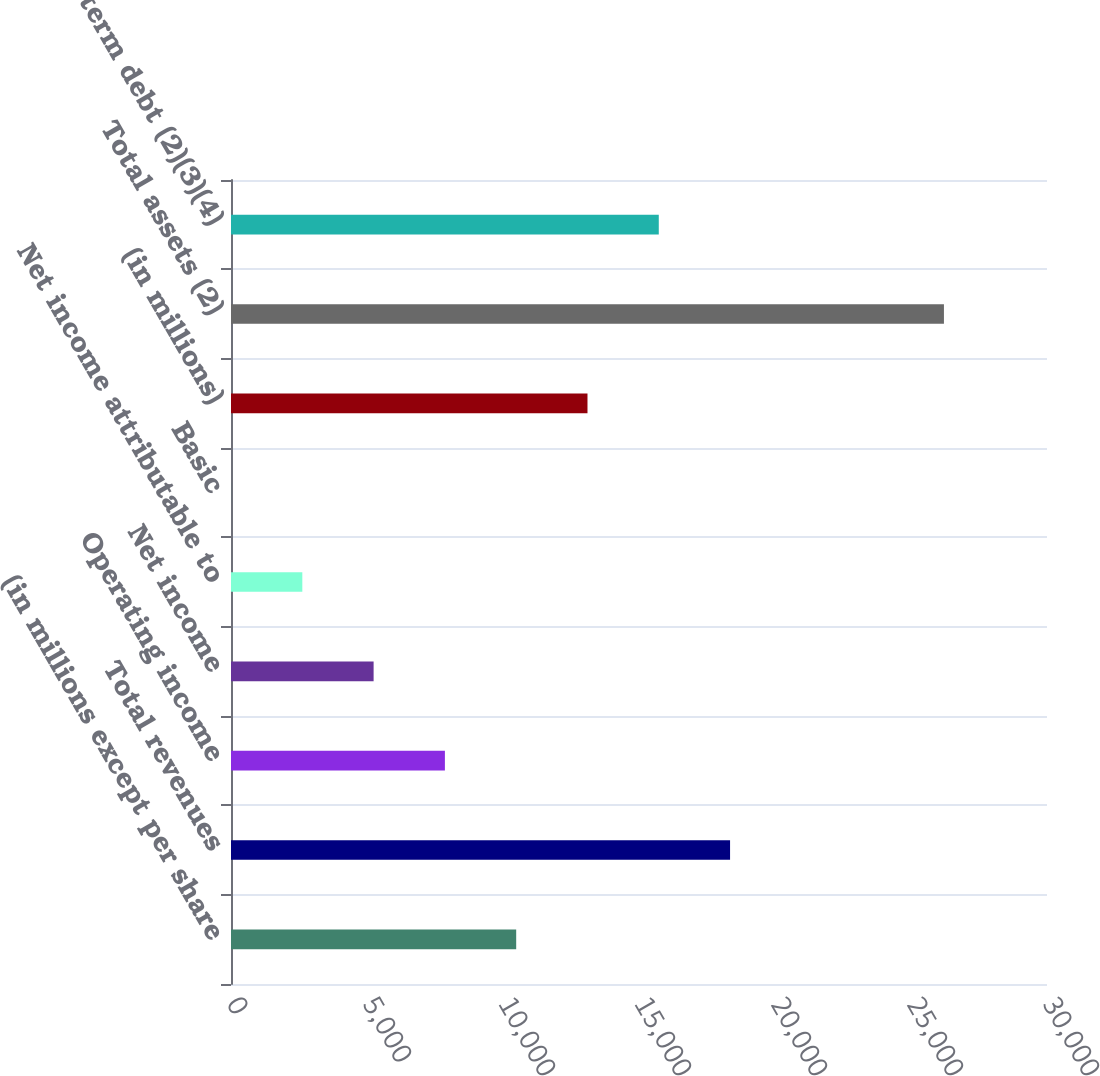Convert chart. <chart><loc_0><loc_0><loc_500><loc_500><bar_chart><fcel>(in millions except per share<fcel>Total revenues<fcel>Operating income<fcel>Net income<fcel>Net income attributable to<fcel>Basic<fcel>(in millions)<fcel>Total assets (2)<fcel>Long-term debt (2)(3)(4)<nl><fcel>10485<fcel>18348<fcel>7864.03<fcel>5243.04<fcel>2622.05<fcel>1.06<fcel>13106<fcel>26211<fcel>15727<nl></chart> 